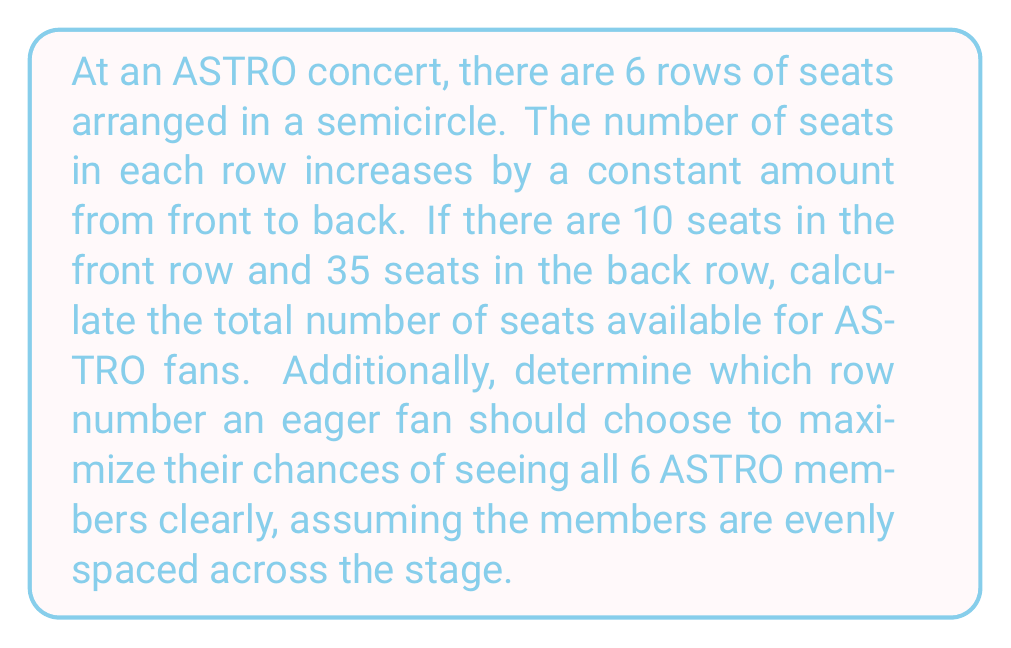Could you help me with this problem? Let's approach this problem step by step:

1) First, we need to find the arithmetic sequence of the number of seats in each row:
   - Front row: 10 seats
   - Back row: 35 seats
   - Number of rows: 6

2) To find the common difference (d) of the arithmetic sequence:
   $$(35 - 10) \div (6 - 1) = 25 \div 5 = 5$$

3) So, the number of seats in each row forms the sequence:
   10, 15, 20, 25, 30, 35

4) To find the total number of seats, we use the arithmetic sequence sum formula:
   $$S_n = \frac{n}{2}(a_1 + a_n)$$
   Where $S_n$ is the sum, $n$ is the number of terms, $a_1$ is the first term, and $a_n$ is the last term.

   $$S_6 = \frac{6}{2}(10 + 35) = 3(45) = 135$$

5) For optimal visibility, we need to consider two factors:
   a) Distance from the stage (closer is generally better)
   b) Width of view (wider allows seeing all members more easily)

6) The middle row offers a balance between these factors:
   - Not too far from the stage
   - Wide enough to see all members

7) The middle row in this case would be the 3rd or 4th row (since there are 6 rows total).

8) Between the 3rd and 4th row, the 4th row is slightly better because:
   - It has more seats (25 vs 20), increasing the chances of getting a good spot
   - It's still close enough to the stage for good visibility
   - The wider arc allows for a better view of all members

[asy]
size(200,100);
for(int i=0; i<6; ++i) {
  draw(arc((0,-50+i*10),50+i*10,180,360));
}
label("Stage", (0,-60));
label("Row 1", (-60,0));
label("Row 6", (-110,50));
label("Best row (4th)", (-85,30), red);
[/asy]
Answer: Total seats: 135
Optimal row for visibility: 4th row 